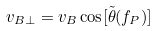Convert formula to latex. <formula><loc_0><loc_0><loc_500><loc_500>v _ { B \bot } = v _ { B } \cos [ \tilde { \theta } ( f _ { P } ) ]</formula> 